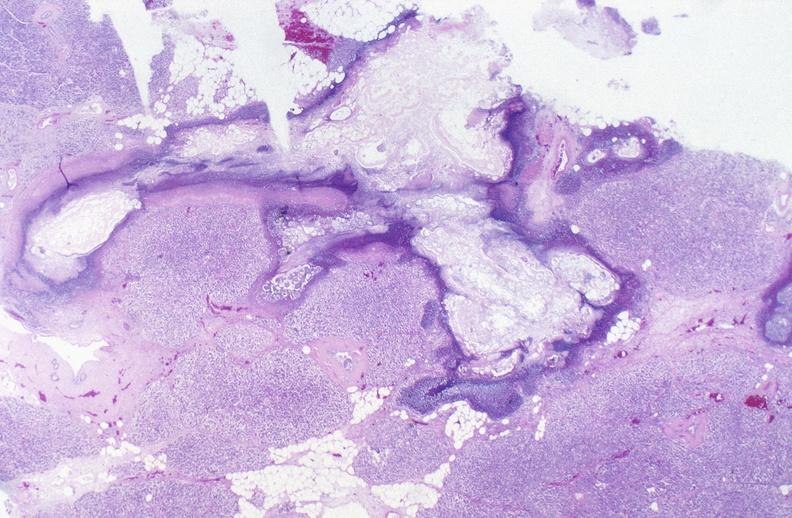where is this?
Answer the question using a single word or phrase. Pancreas 